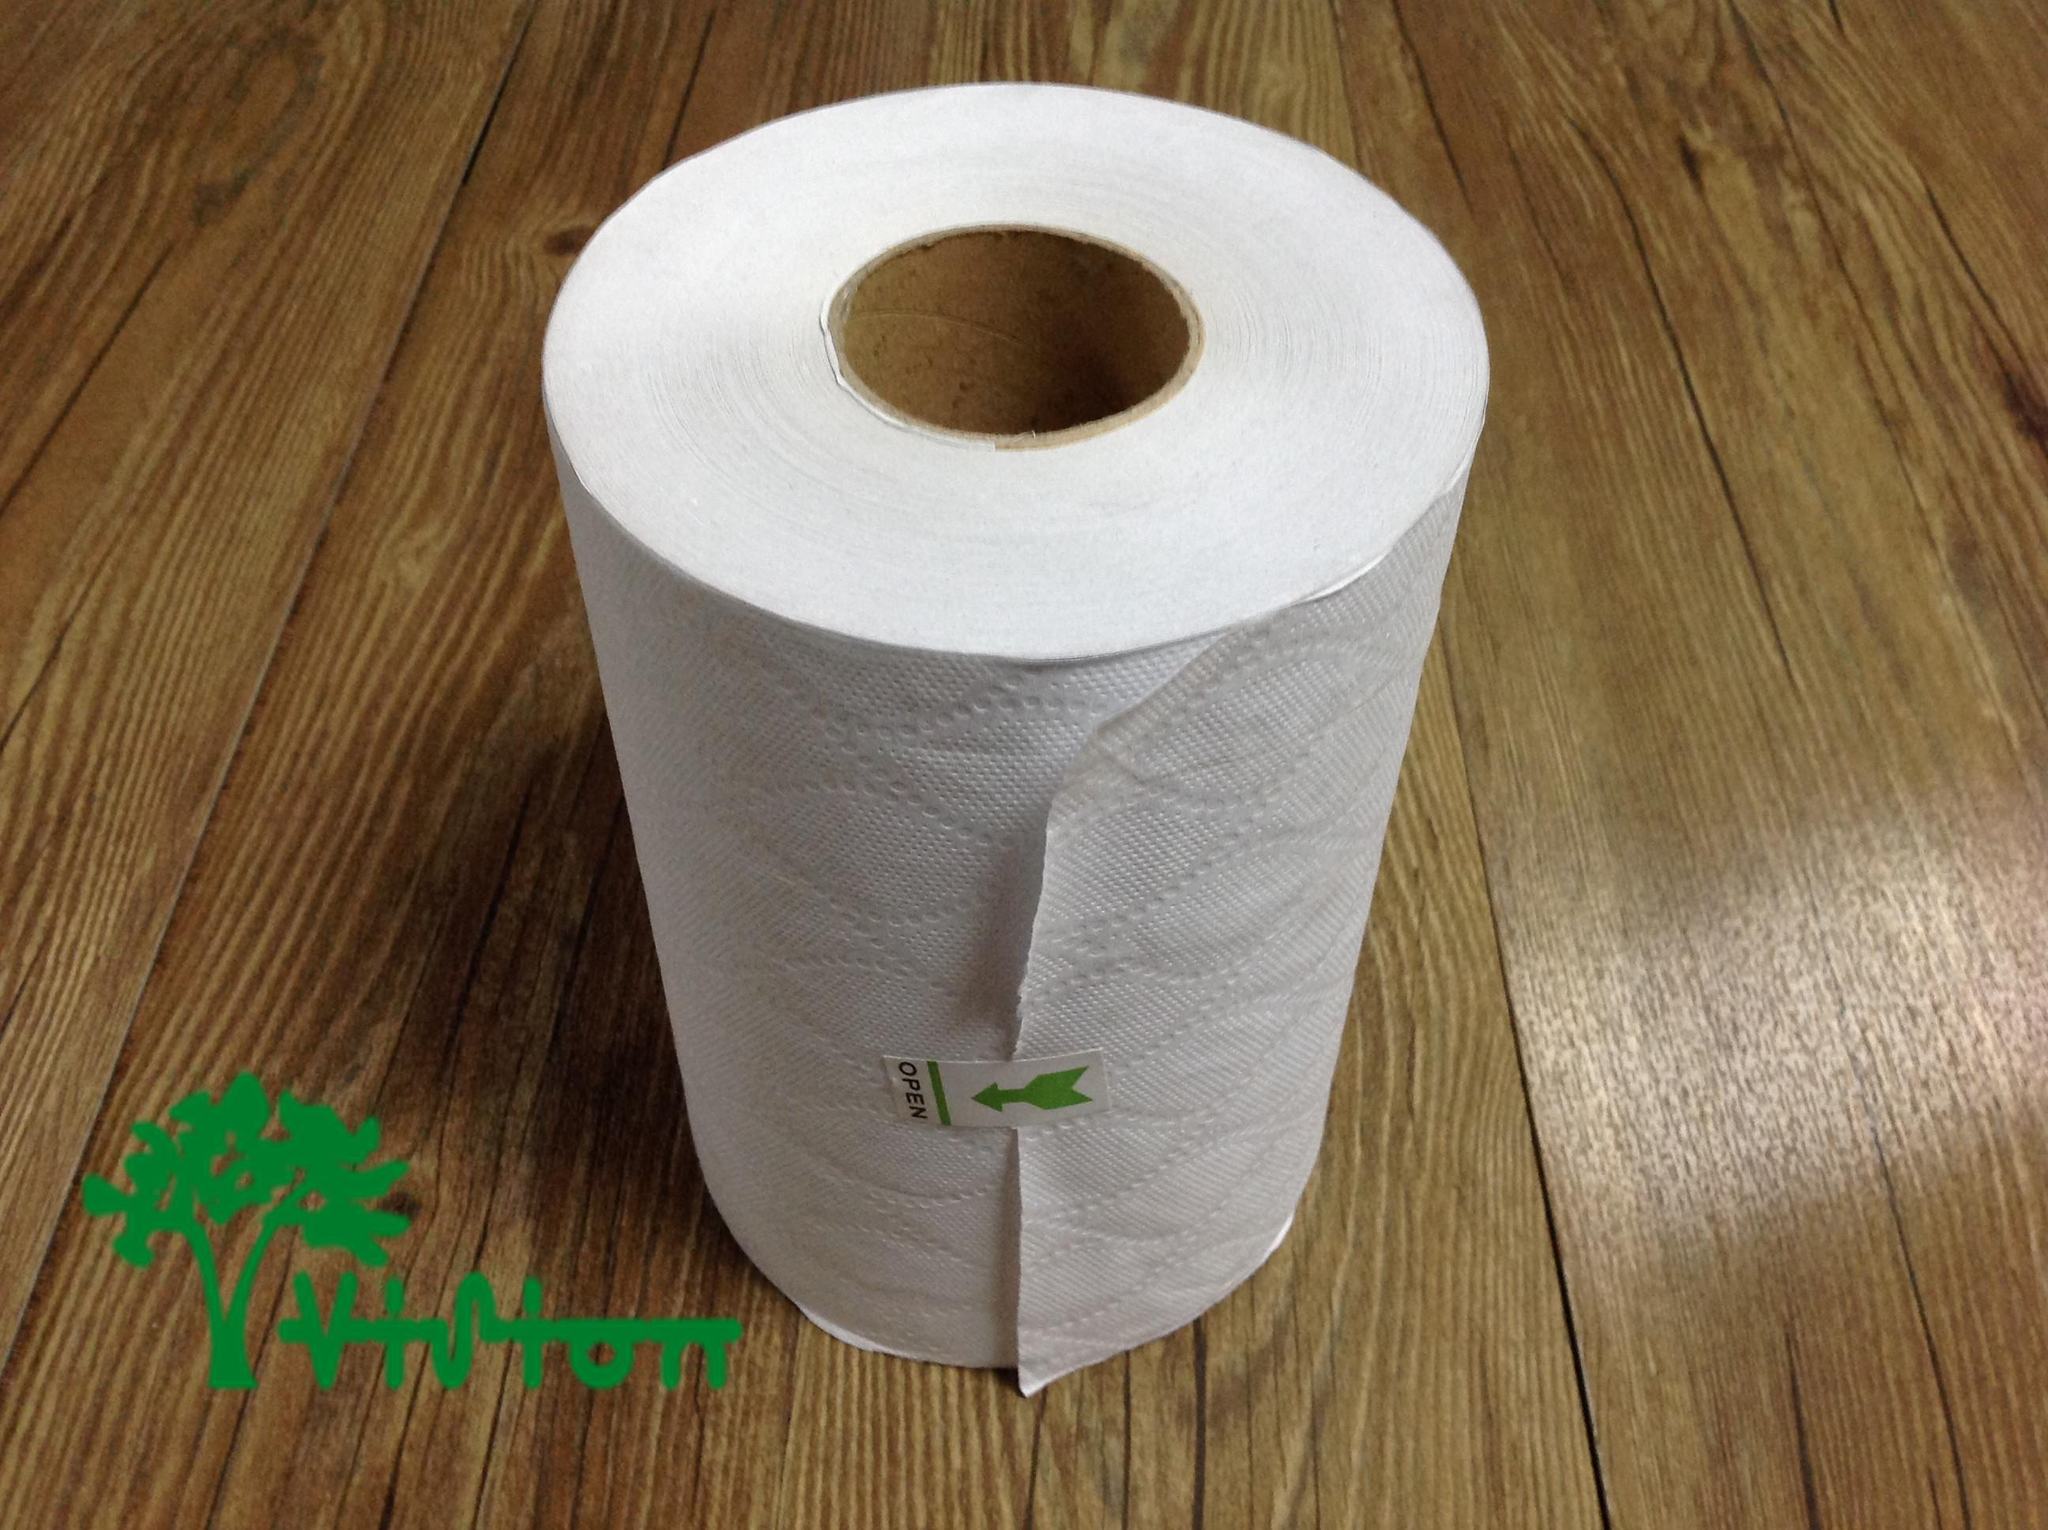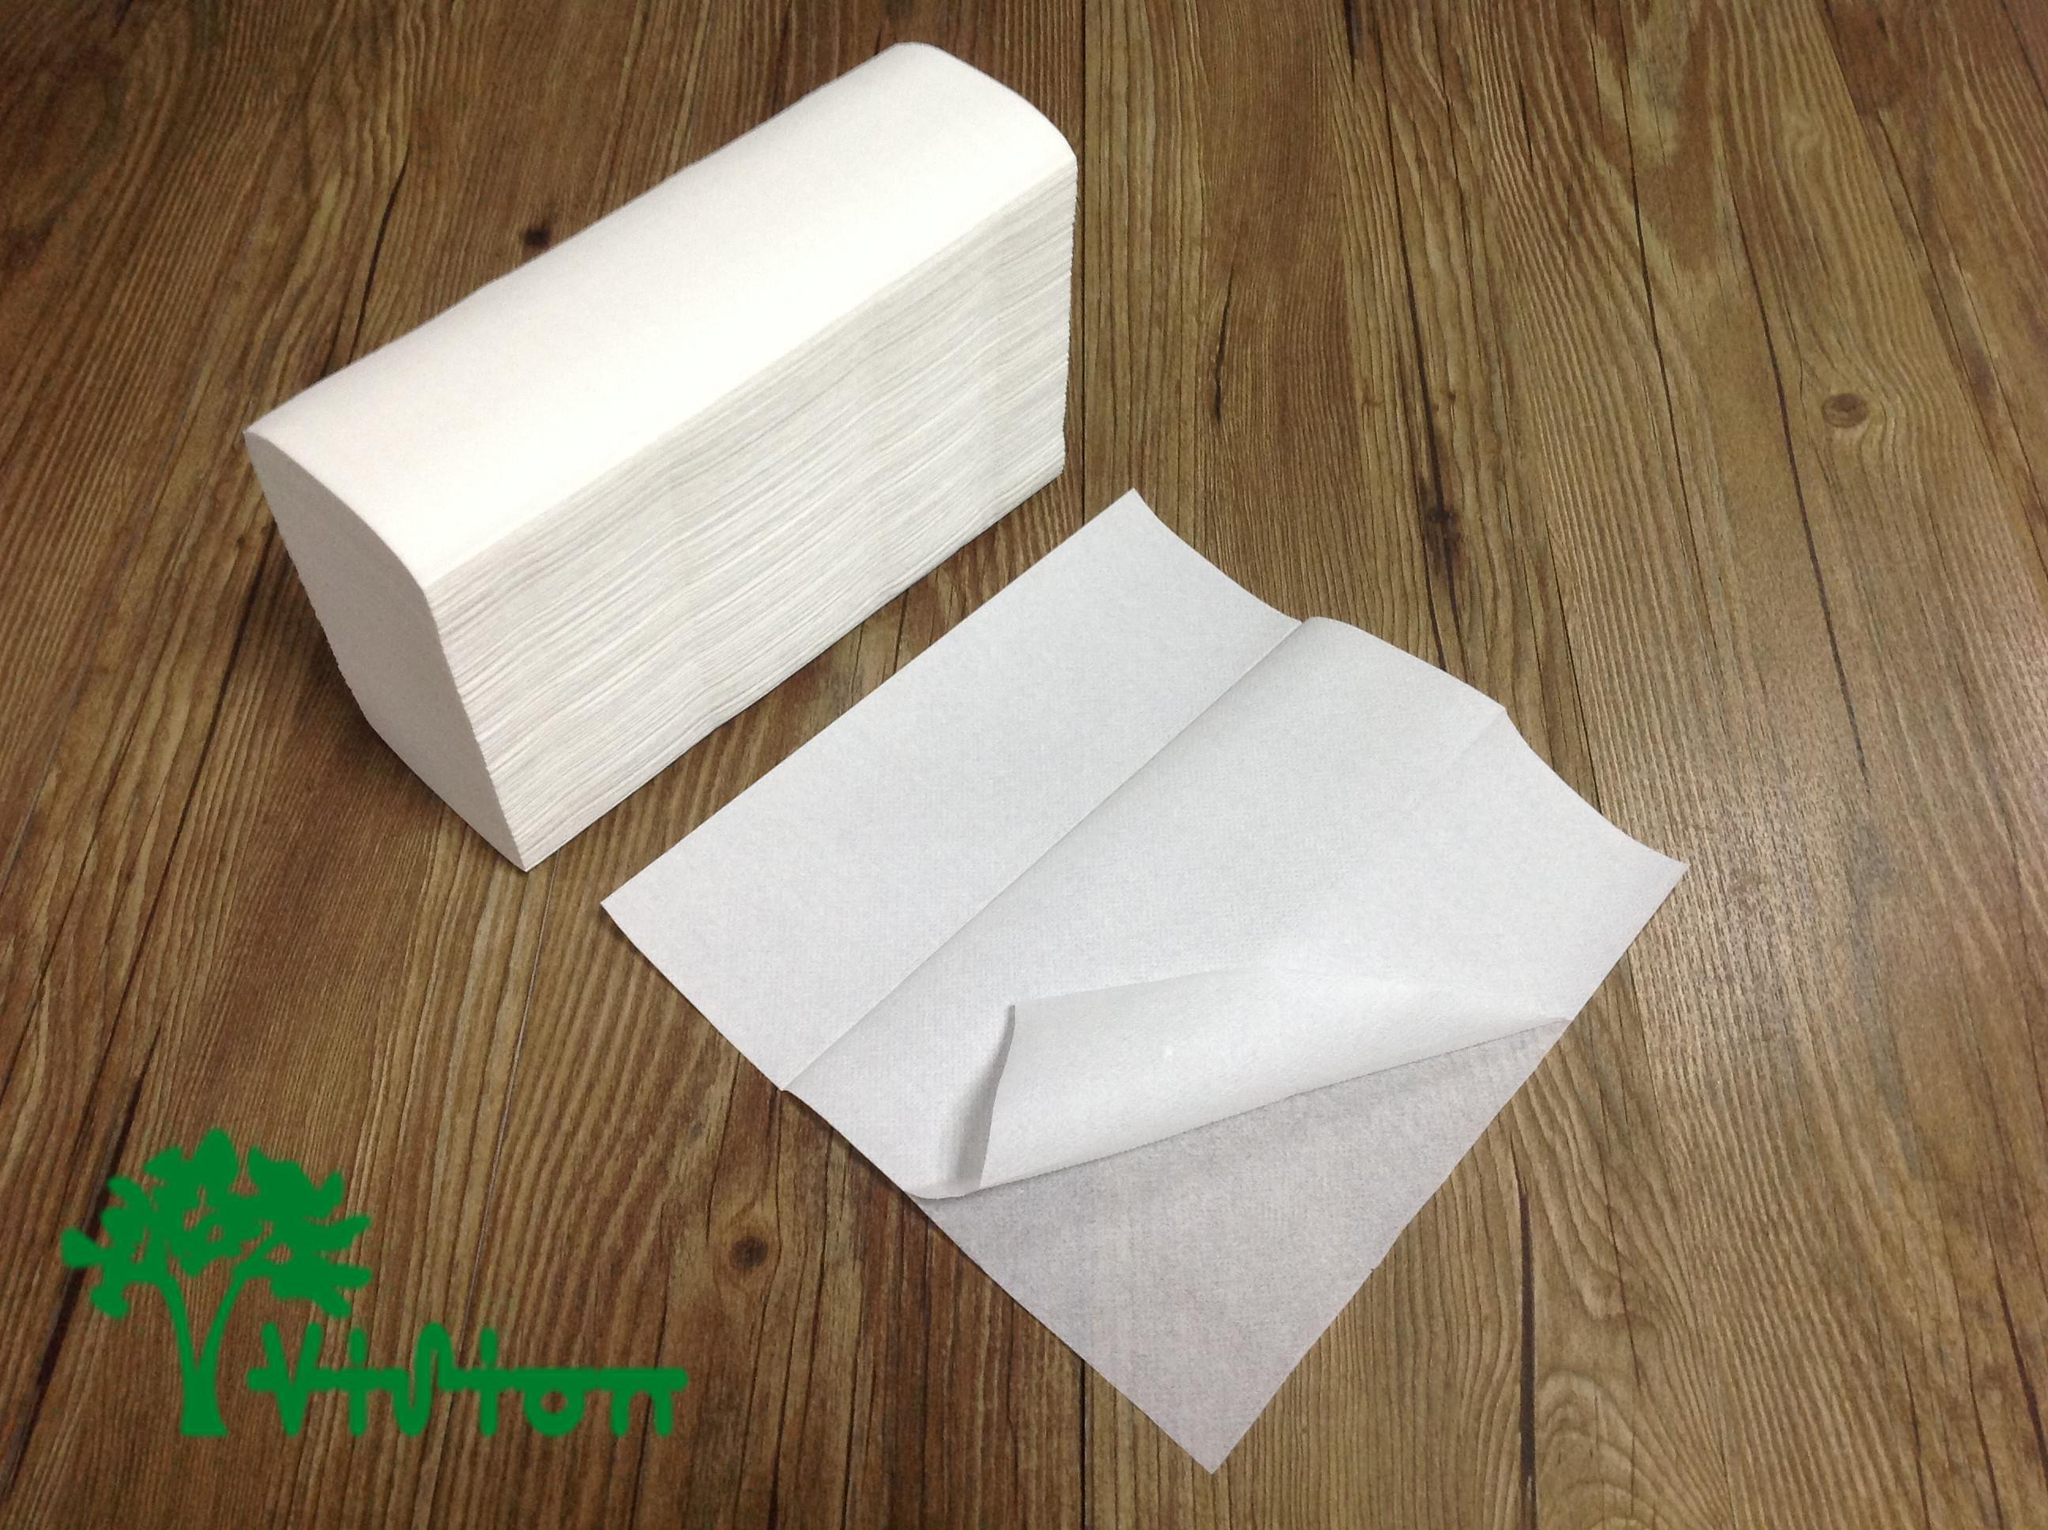The first image is the image on the left, the second image is the image on the right. Evaluate the accuracy of this statement regarding the images: "There are two rolls lying on a wooden surface.". Is it true? Answer yes or no. No. 